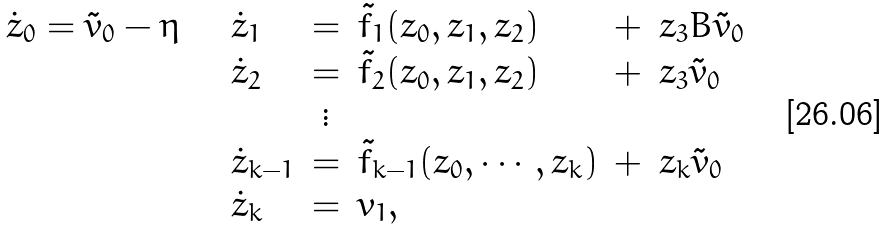<formula> <loc_0><loc_0><loc_500><loc_500>\begin{array} { l l c l c l } \dot { z } _ { 0 } = \tilde { v } _ { 0 } - \eta \quad & \dot { z } _ { 1 } & = & \tilde { f } _ { 1 } ( z _ { 0 } , z _ { 1 } , z _ { 2 } ) & + & z _ { 3 } B \tilde { v } _ { 0 } \\ & \dot { z } _ { 2 } & = & \tilde { f } _ { 2 } ( z _ { 0 } , z _ { 1 } , z _ { 2 } ) & + & z _ { 3 } \tilde { v } _ { 0 } \\ & & \vdots & & & \\ & \dot { z } _ { k - 1 } & = & \tilde { f } _ { k - 1 } ( z _ { 0 } , \cdots , z _ { k } ) & + & z _ { k } \tilde { v } _ { 0 } \\ & \dot { z } _ { k } & = & v _ { 1 } , & & \end{array}</formula> 